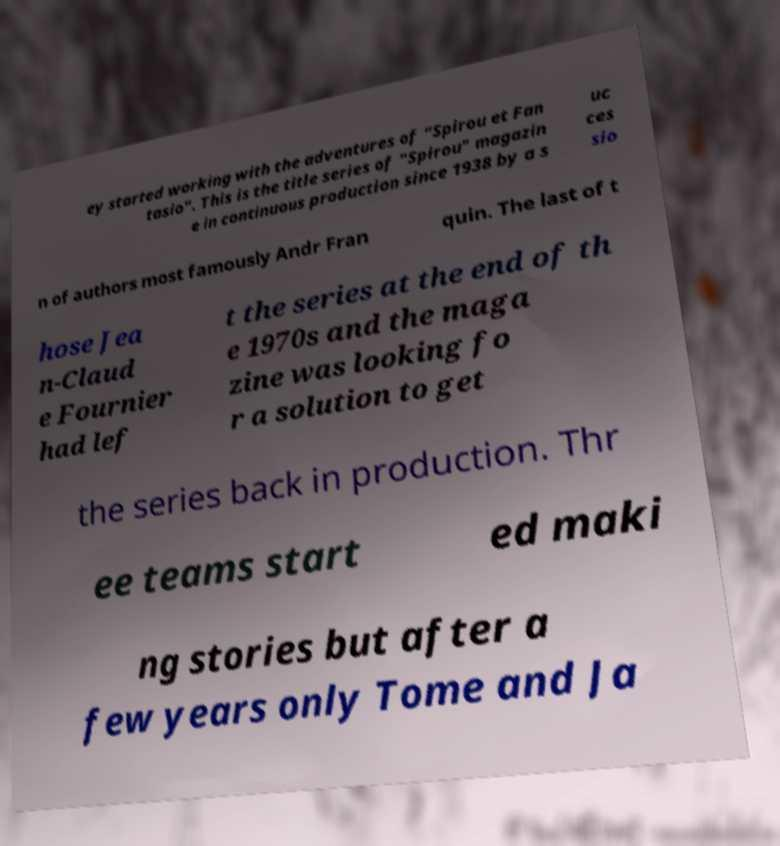Can you read and provide the text displayed in the image?This photo seems to have some interesting text. Can you extract and type it out for me? ey started working with the adventures of "Spirou et Fan tasio". This is the title series of "Spirou" magazin e in continuous production since 1938 by a s uc ces sio n of authors most famously Andr Fran quin. The last of t hose Jea n-Claud e Fournier had lef t the series at the end of th e 1970s and the maga zine was looking fo r a solution to get the series back in production. Thr ee teams start ed maki ng stories but after a few years only Tome and Ja 